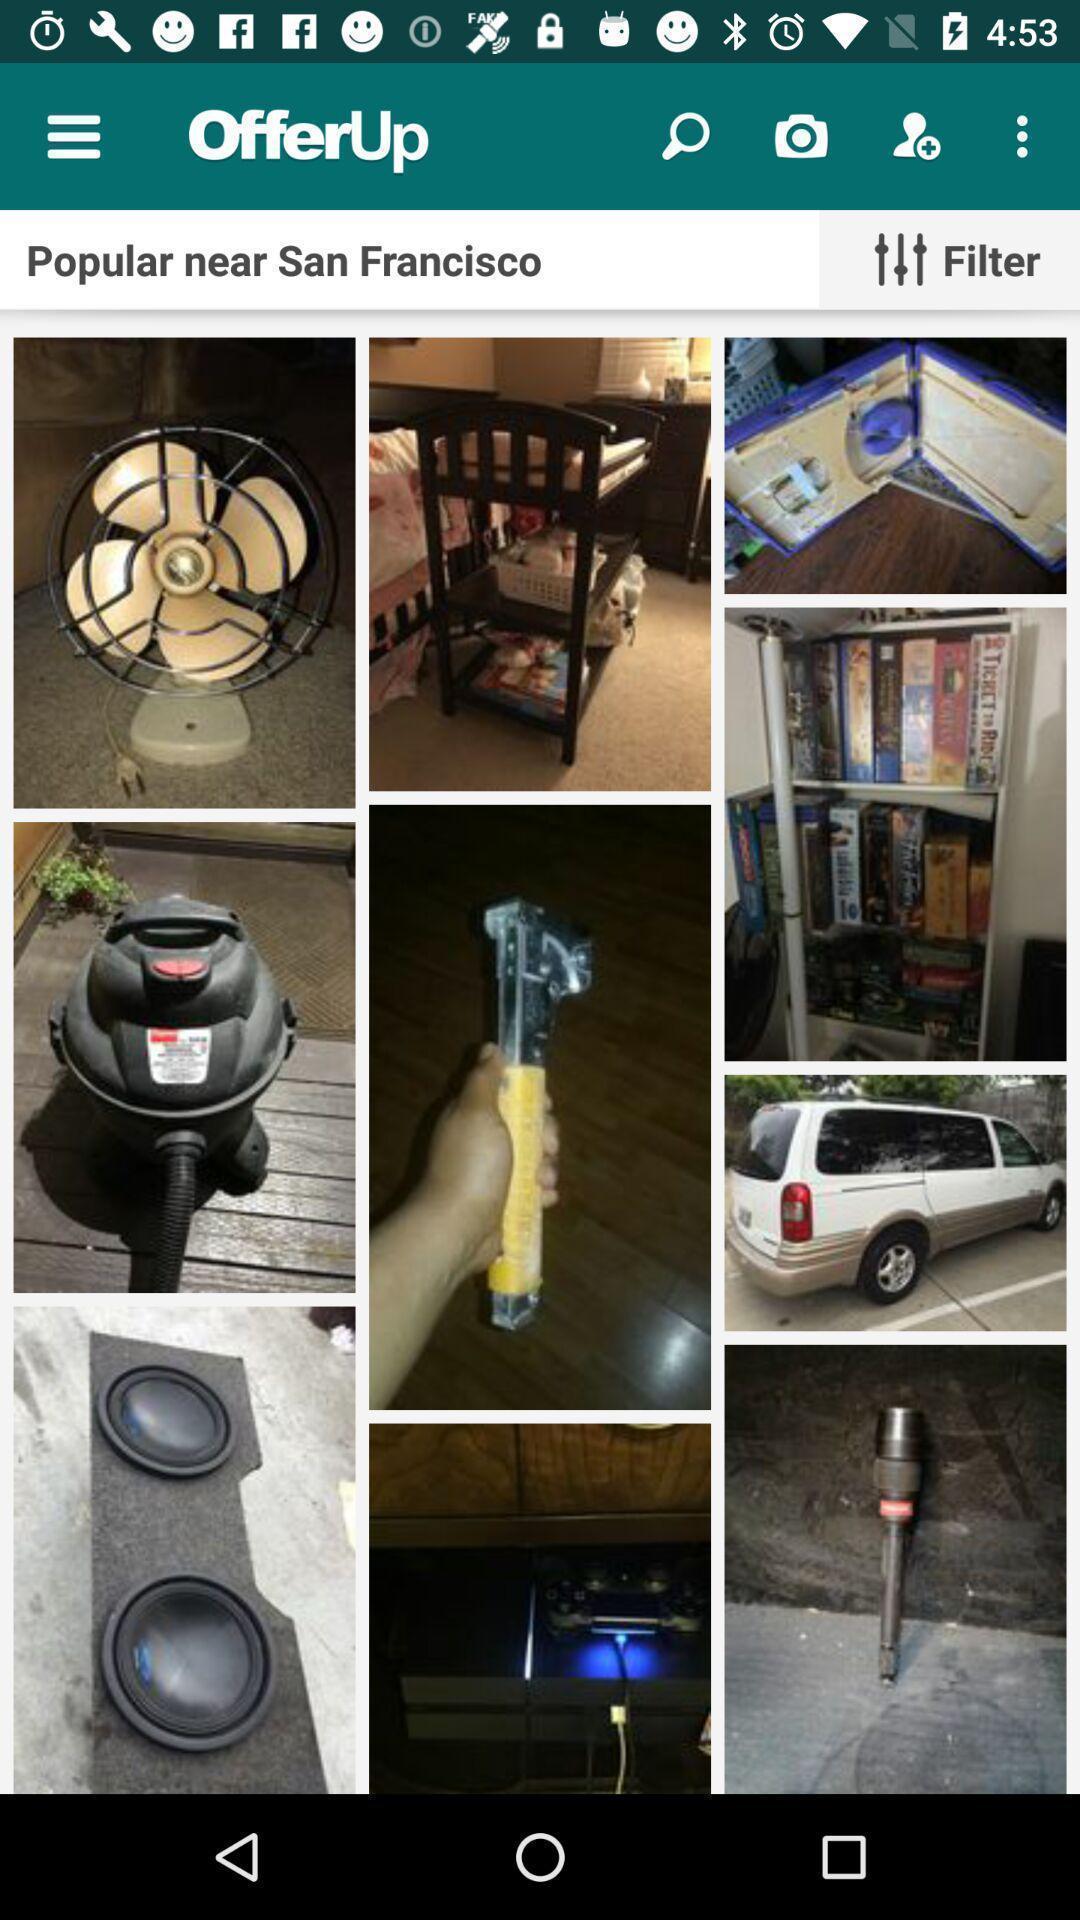Explain what's happening in this screen capture. Search result page of online marketplace app. 